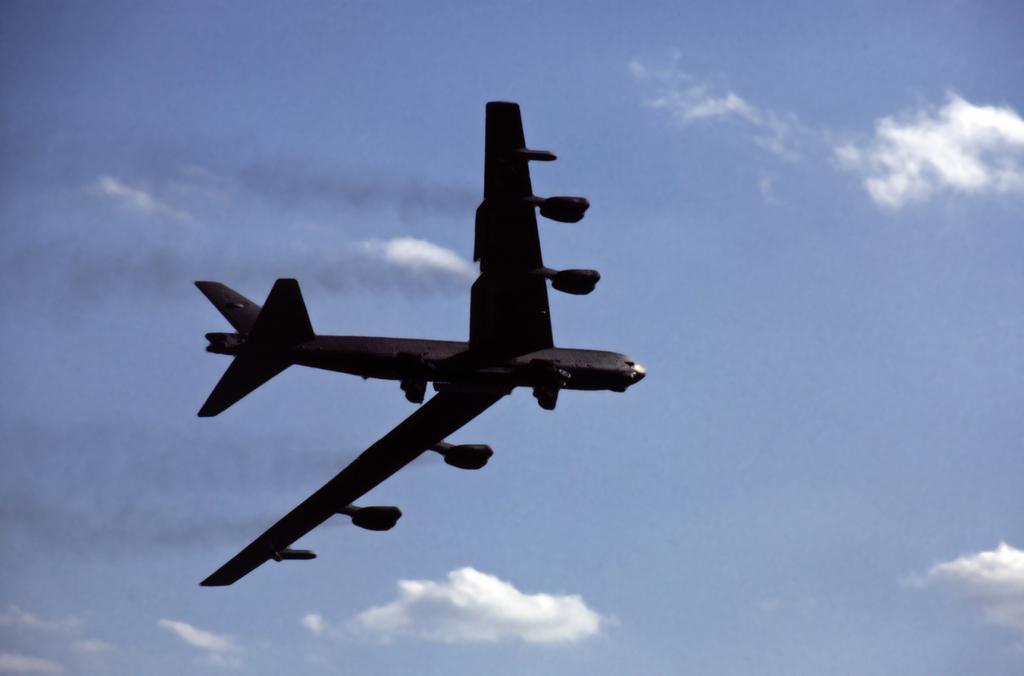In one or two sentences, can you explain what this image depicts? In this picture, we see aeroplane which is flying in air. Behind that, we see sky which is blue in color and we even see clouds. 